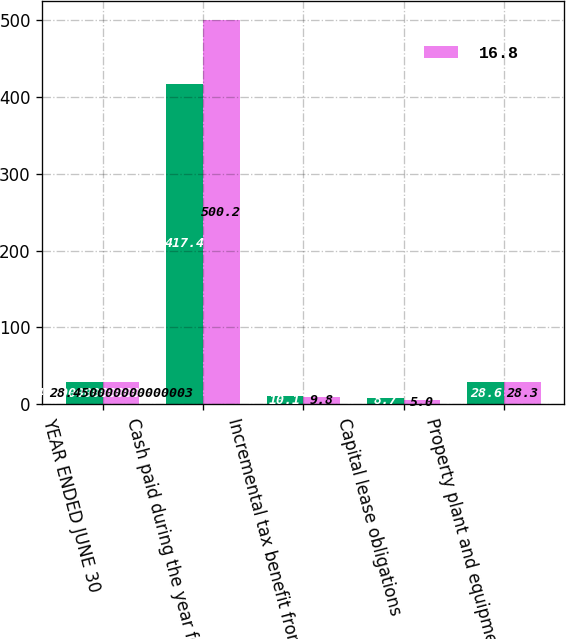Convert chart. <chart><loc_0><loc_0><loc_500><loc_500><stacked_bar_chart><ecel><fcel>YEAR ENDED JUNE 30<fcel>Cash paid during the year for<fcel>Incremental tax benefit from<fcel>Capital lease obligations<fcel>Property plant and equipment<nl><fcel>nan<fcel>28.45<fcel>417.4<fcel>10.1<fcel>8.7<fcel>28.6<nl><fcel>16.8<fcel>28.45<fcel>500.2<fcel>9.8<fcel>5<fcel>28.3<nl></chart> 